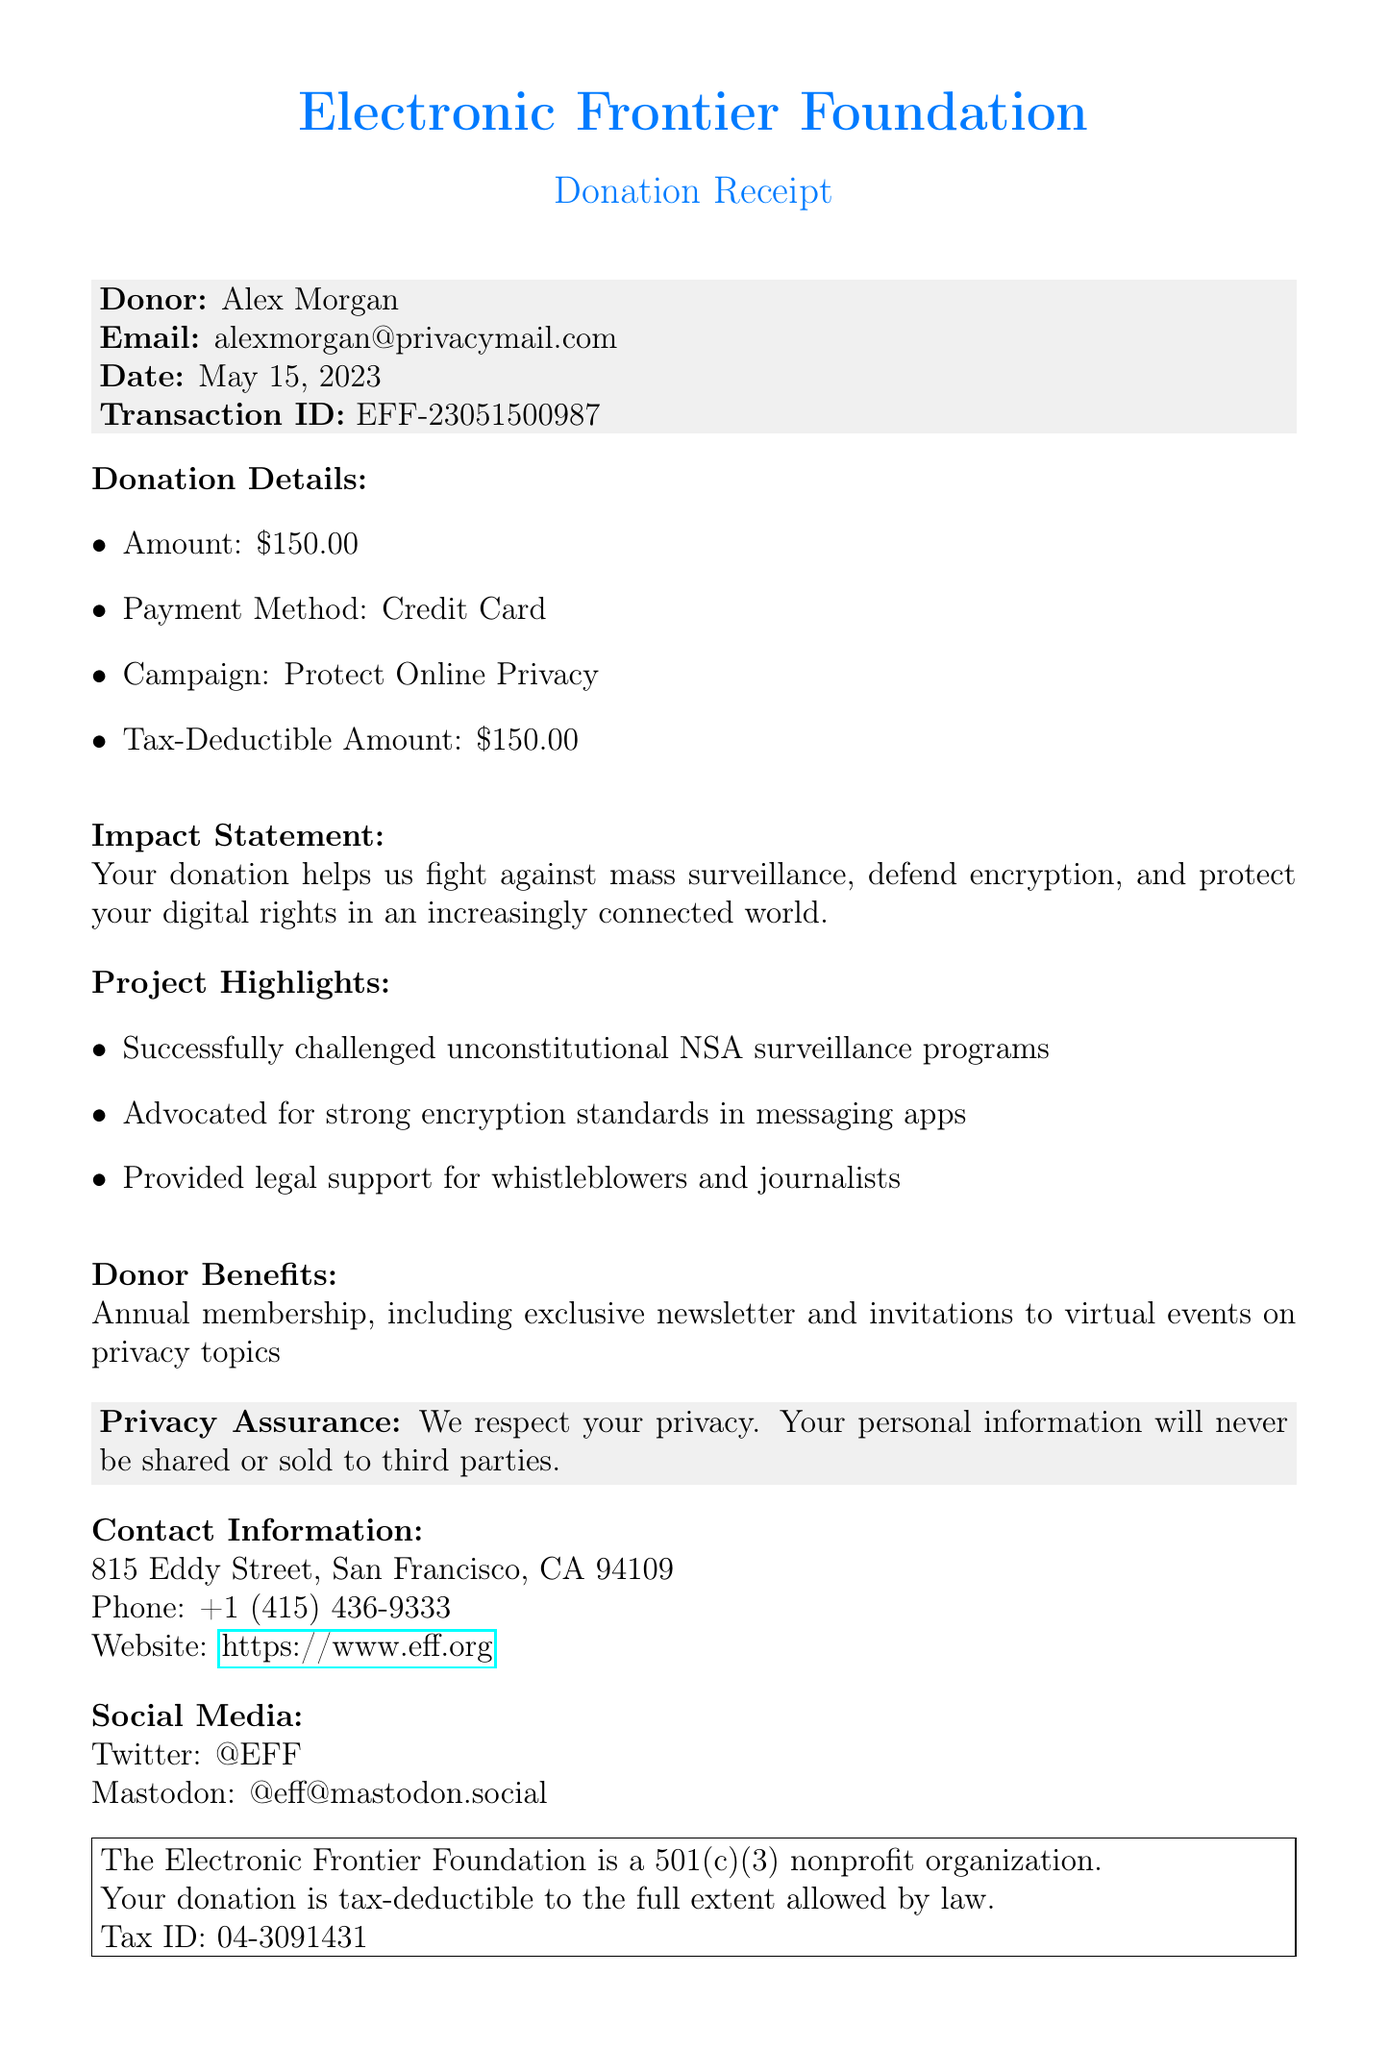What is the organization name? The organization name can be found at the top of the document.
Answer: Electronic Frontier Foundation What is the donor's email address? The donor's email is listed under the donor information section.
Answer: alexmorgan@privacymail.com What is the donation amount? The donation amount is explicitly stated in the donation details section.
Answer: $150.00 What is the tax-deductible amount? The tax-deductible amount matches the donation amount and is specified in the donation details.
Answer: $150.00 What date was the donation made? The donation date is provided alongside the donor's information.
Answer: May 15, 2023 What is the transaction ID? The transaction ID is listed under the donor information section.
Answer: EFF-23051500987 How many project highlights are mentioned? The number of project highlights can be counted in the respective section.
Answer: 3 What is stated about donor benefits? The donor benefits are detailed in a dedicated section of the receipt.
Answer: Annual membership, including exclusive newsletter and invitations to virtual events on privacy topics What is the tax ID number? The tax ID number is mentioned in the receipt footer section.
Answer: 04-3091431 What assurance is provided regarding privacy? The privacy assurance is included in the document to inform the donor about data protection.
Answer: We respect your privacy. Your personal information will never be shared or sold to third parties 